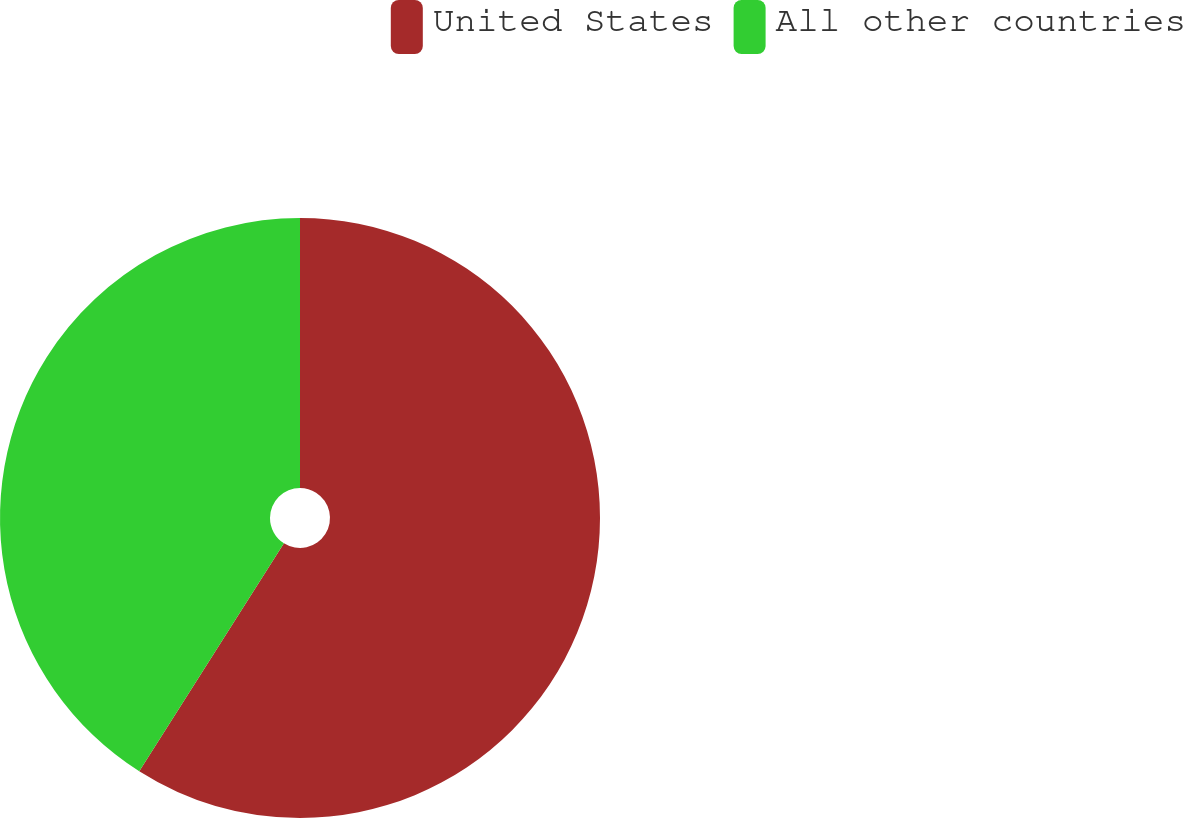Convert chart to OTSL. <chart><loc_0><loc_0><loc_500><loc_500><pie_chart><fcel>United States<fcel>All other countries<nl><fcel>59.0%<fcel>41.0%<nl></chart> 